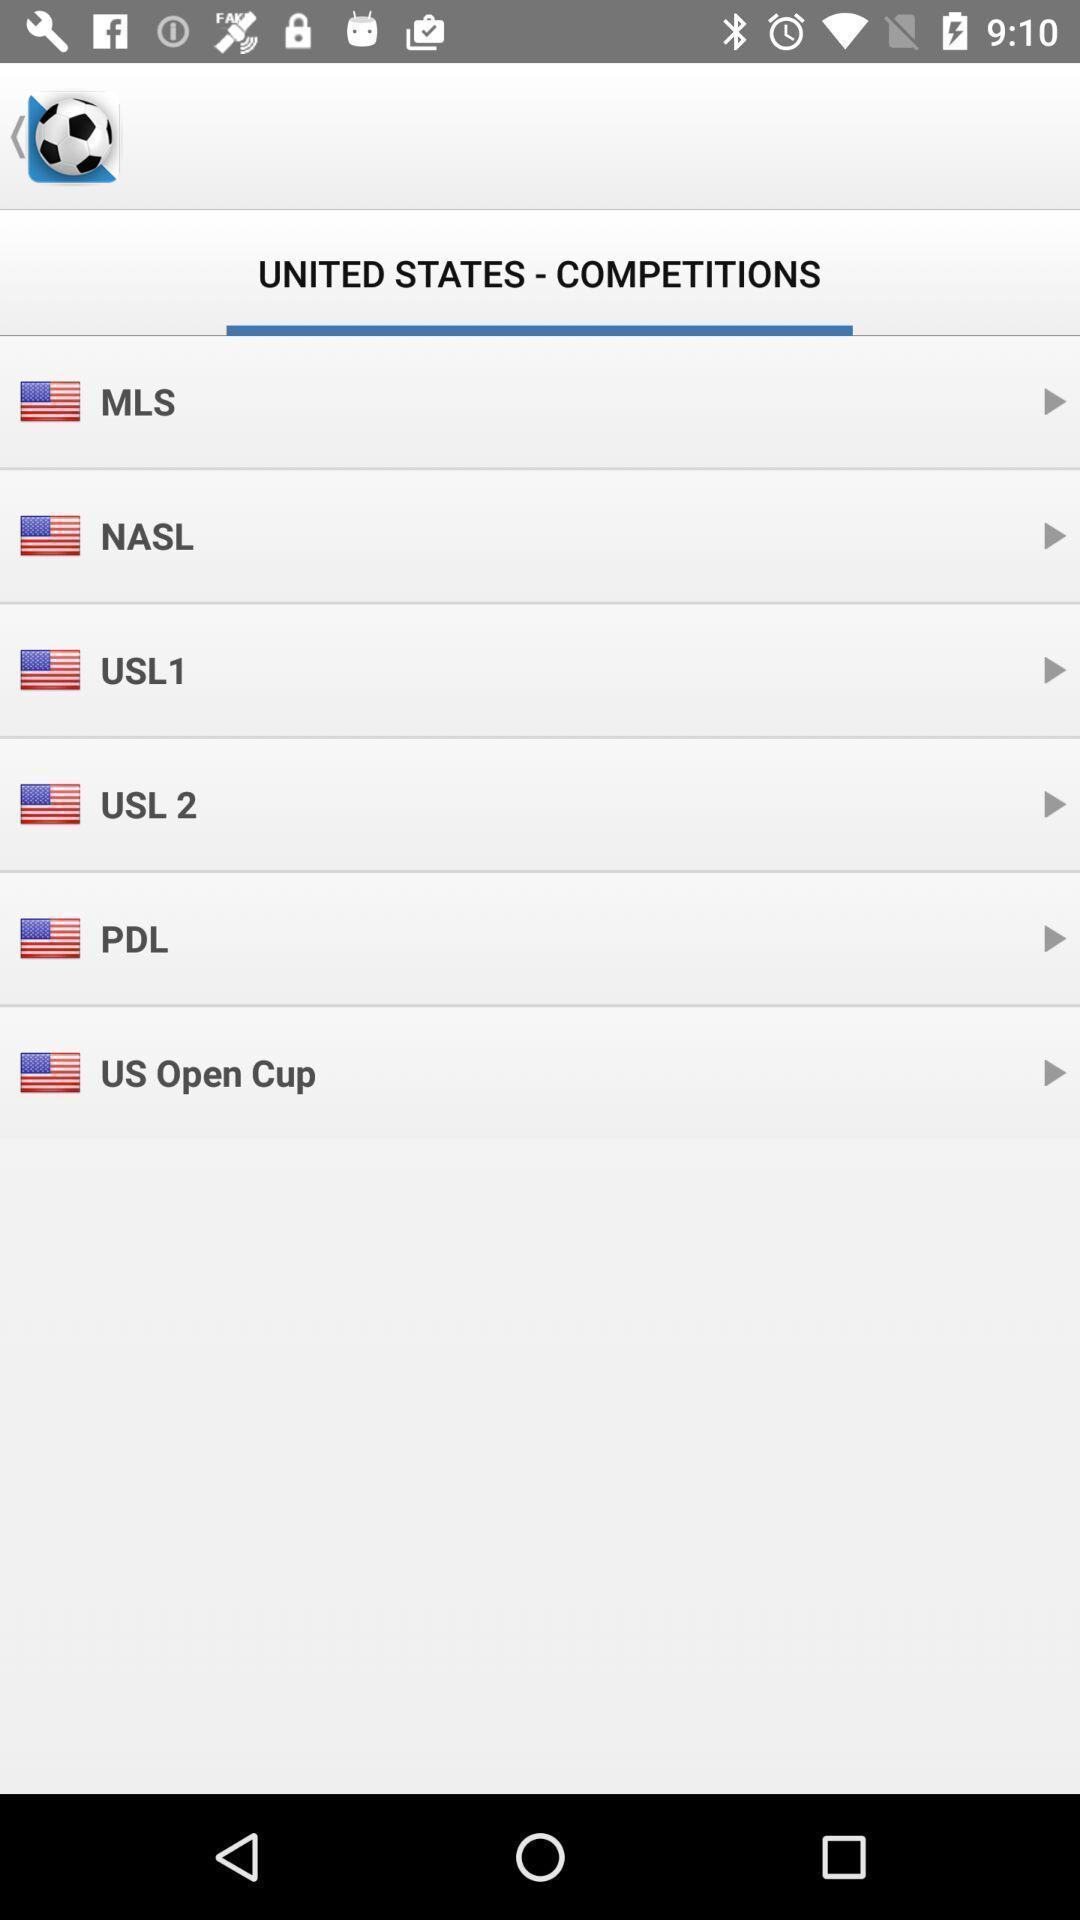Tell me what you see in this picture. Page that displaying sports application. 